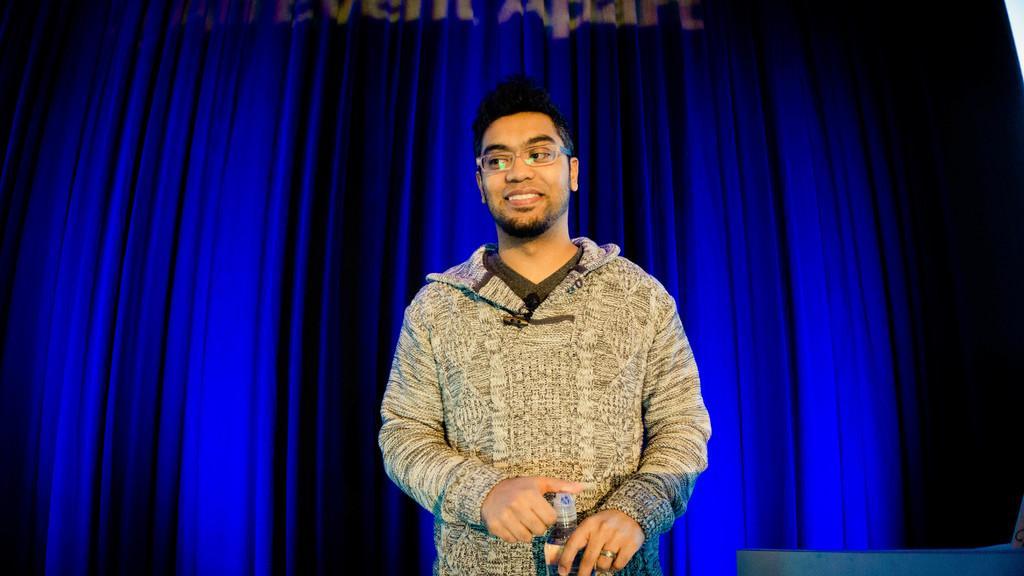Can you describe this image briefly? In the center of the image there is a person holding a bottle in his hand. In the background of the image there is a blue color curtain. 